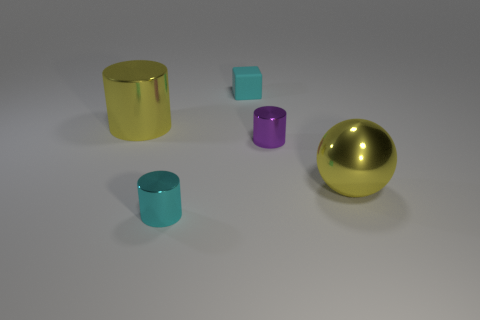The big shiny thing that is the same color as the metal sphere is what shape?
Provide a succinct answer. Cylinder. What color is the sphere?
Provide a short and direct response. Yellow. What size is the yellow thing left of the block?
Offer a terse response. Large. What number of cylinders are behind the yellow object that is on the right side of the small shiny object right of the cyan rubber object?
Make the answer very short. 2. The large metal thing that is behind the tiny cylinder that is on the right side of the cube is what color?
Your response must be concise. Yellow. Is there a yellow metallic cylinder that has the same size as the purple metallic cylinder?
Make the answer very short. No. The tiny cylinder that is in front of the small metallic thing behind the yellow metallic thing to the right of the small matte object is made of what material?
Make the answer very short. Metal. What number of blocks are on the right side of the small metallic object behind the cyan shiny thing?
Offer a very short reply. 0. There is a yellow shiny thing to the right of the rubber object; is it the same size as the matte cube?
Provide a succinct answer. No. What number of cyan shiny things have the same shape as the purple metallic thing?
Provide a short and direct response. 1. 